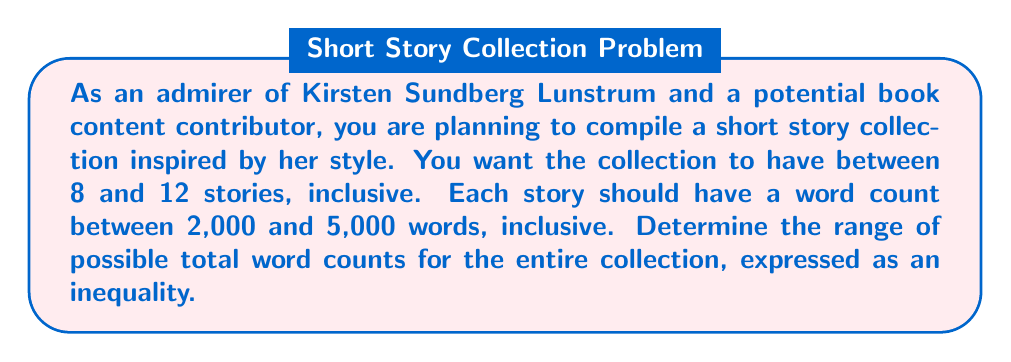Can you answer this question? To solve this problem, we need to consider the minimum and maximum possible word counts for the entire collection.

1. Minimum word count:
   - Minimum number of stories: 8
   - Minimum words per story: 2,000
   - Minimum total: $8 \times 2,000 = 16,000$ words

2. Maximum word count:
   - Maximum number of stories: 12
   - Maximum words per story: 5,000
   - Maximum total: $12 \times 5,000 = 60,000$ words

3. Expressing the range as an inequality:
   Let $x$ be the total word count of the collection.
   The inequality can be written as:

   $$16,000 \leq x \leq 60,000$$

   This inequality represents all possible word counts between the minimum and maximum, inclusive.
Answer: $$16,000 \leq x \leq 60,000$$, where $x$ is the total word count of the short story collection. 